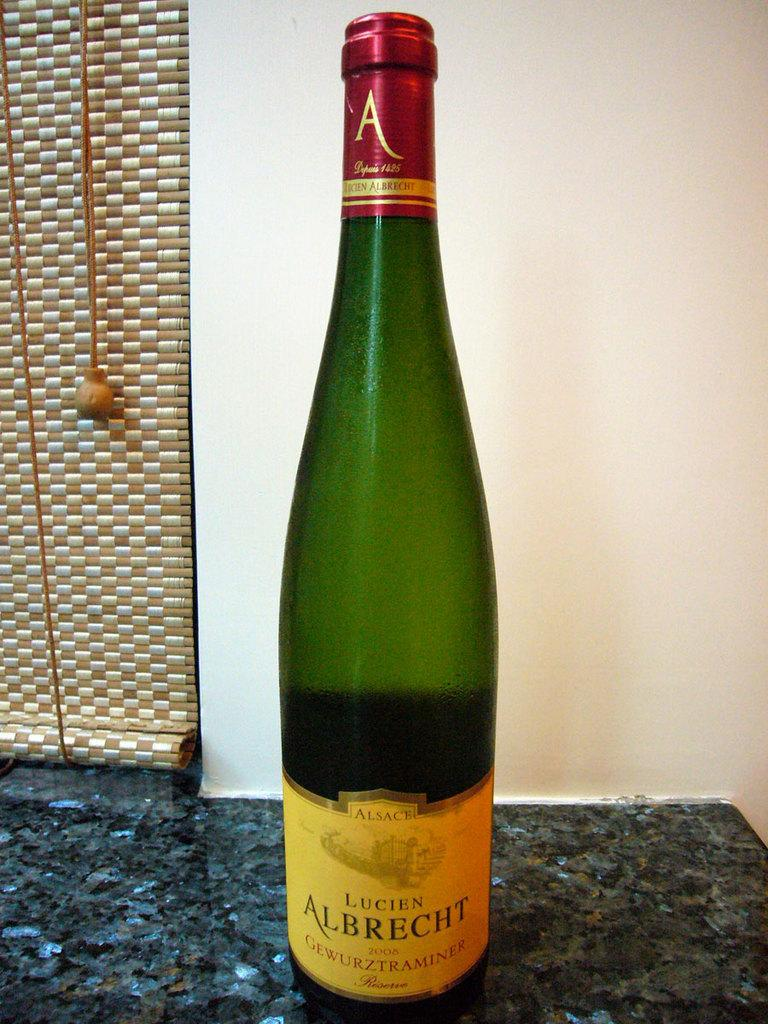<image>
Render a clear and concise summary of the photo. A bottle of Lucien Albrecht sits on a counter top. 